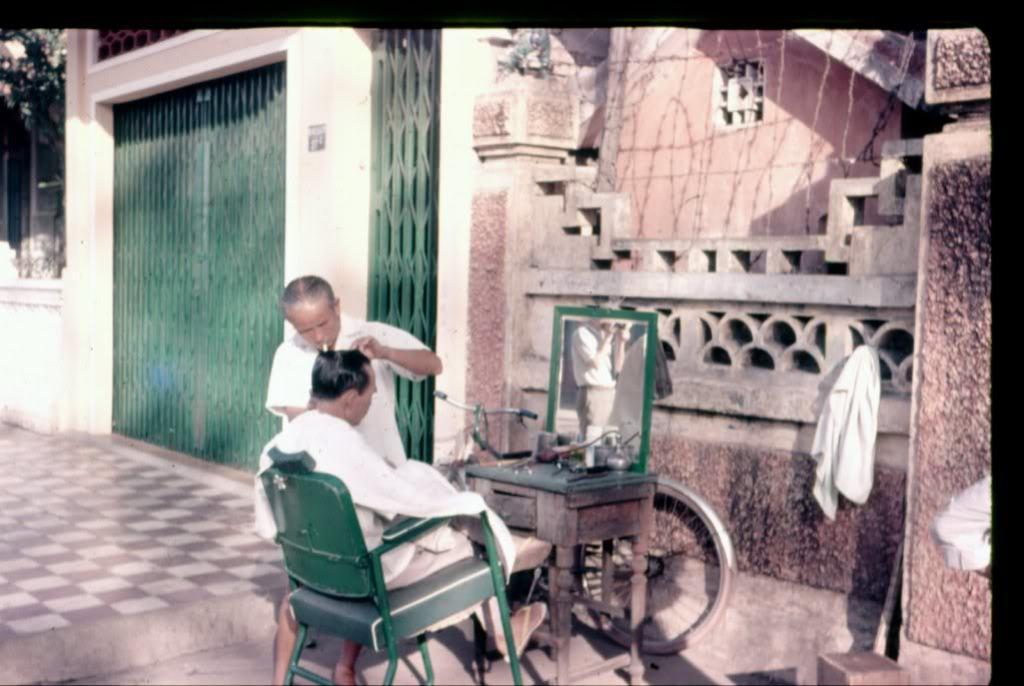In one or two sentences, can you explain what this image depicts? In this image I can see a man sitting on the chair. Beside him there is another person standing and looking at this person. In front of this man there is a table, on that a mirror and few glasses are placed. In the background there is a building. 